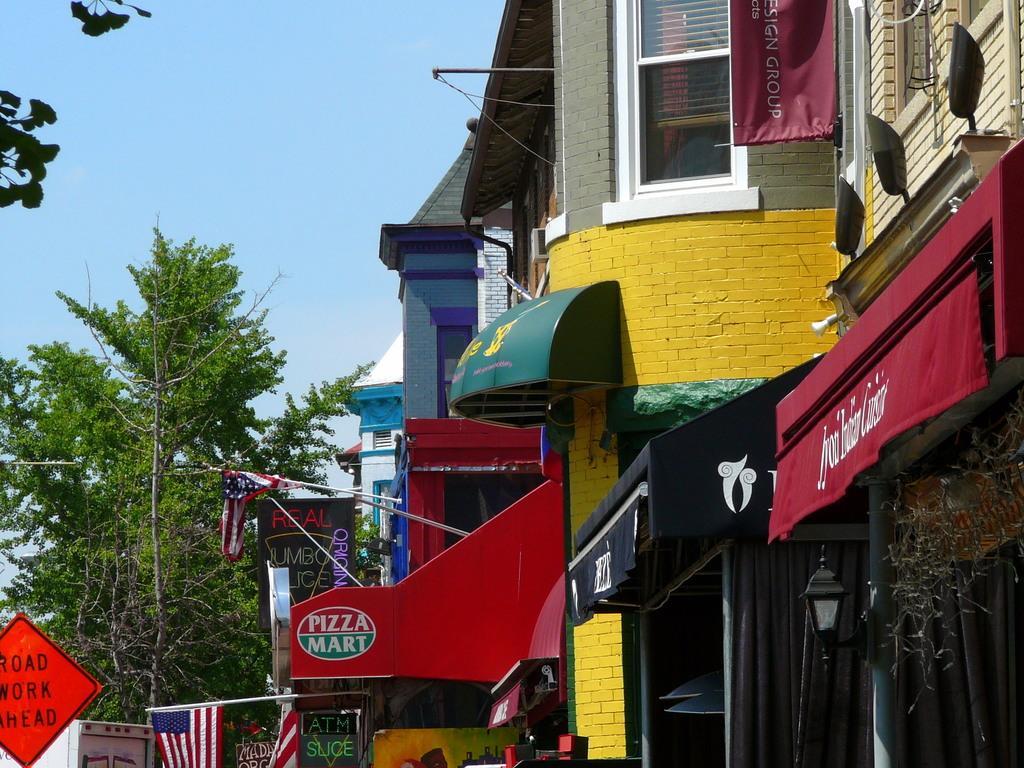Please provide a concise description of this image. In this image, we can see buildings, banners, boards, flags, sign boards and name boards, trees and lights. At the top, there is sky. 